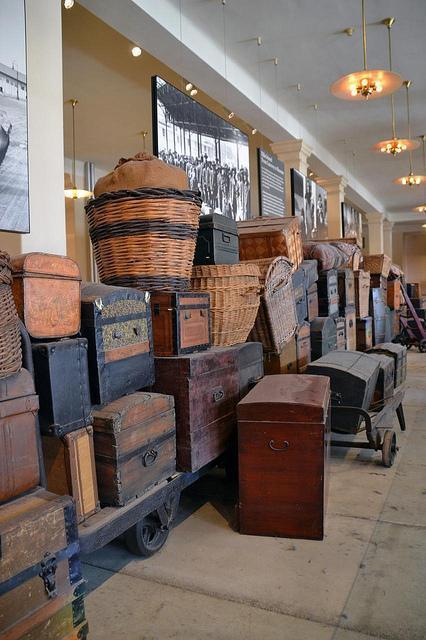What are the largest rectangular clothing item storage pieces called?
Answer the question by selecting the correct answer among the 4 following choices.
Options: Suitcases, valises, baskets, trunks. Trunks. 